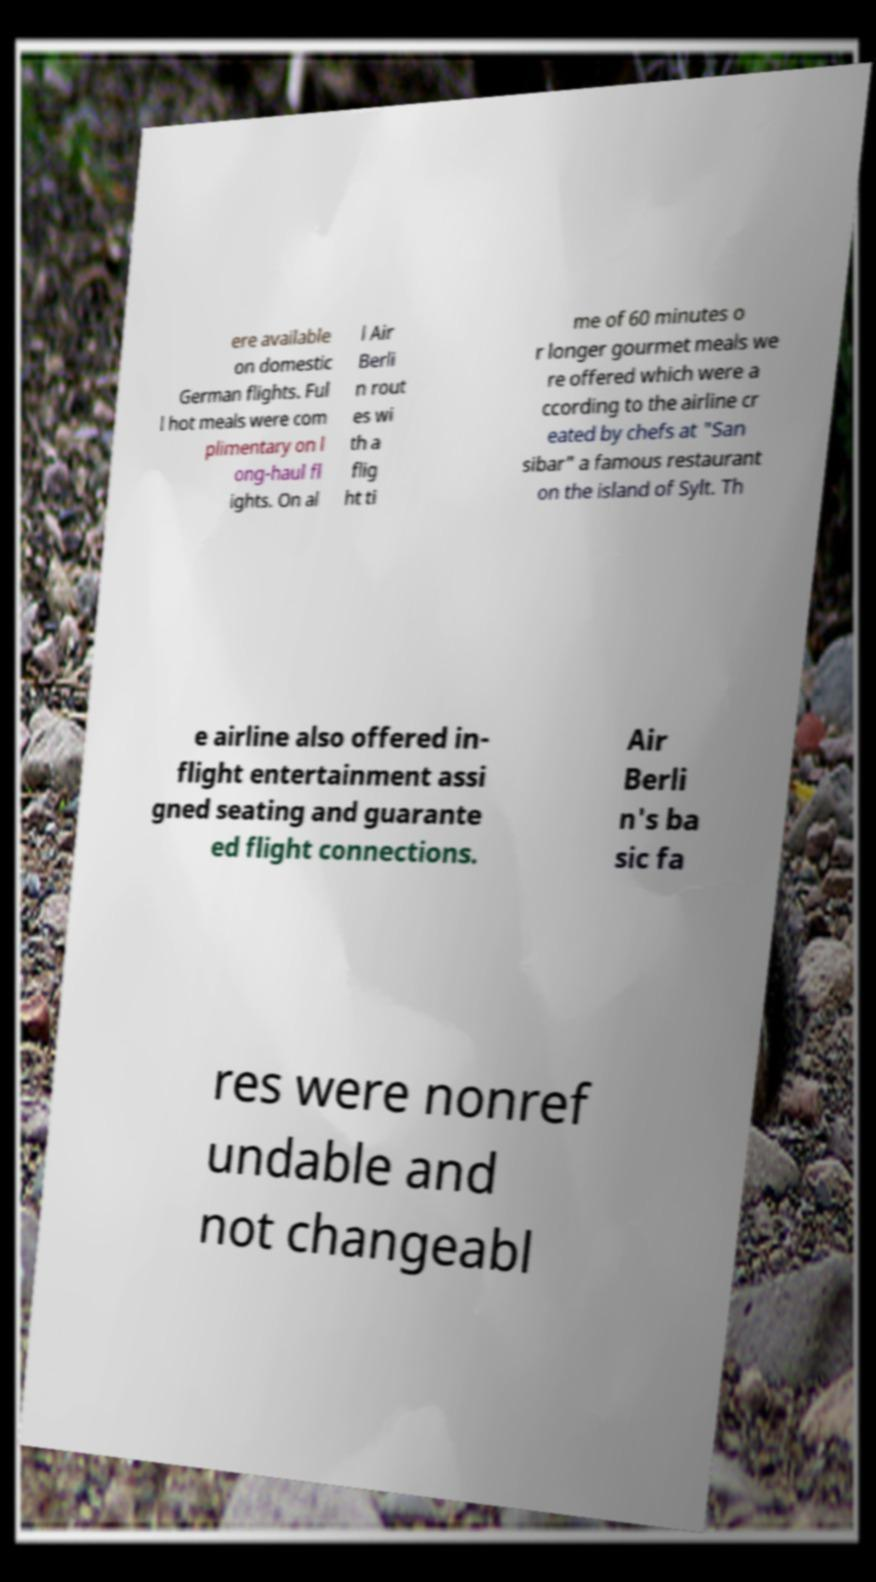Could you assist in decoding the text presented in this image and type it out clearly? ere available on domestic German flights. Ful l hot meals were com plimentary on l ong-haul fl ights. On al l Air Berli n rout es wi th a flig ht ti me of 60 minutes o r longer gourmet meals we re offered which were a ccording to the airline cr eated by chefs at "San sibar" a famous restaurant on the island of Sylt. Th e airline also offered in- flight entertainment assi gned seating and guarante ed flight connections. Air Berli n's ba sic fa res were nonref undable and not changeabl 